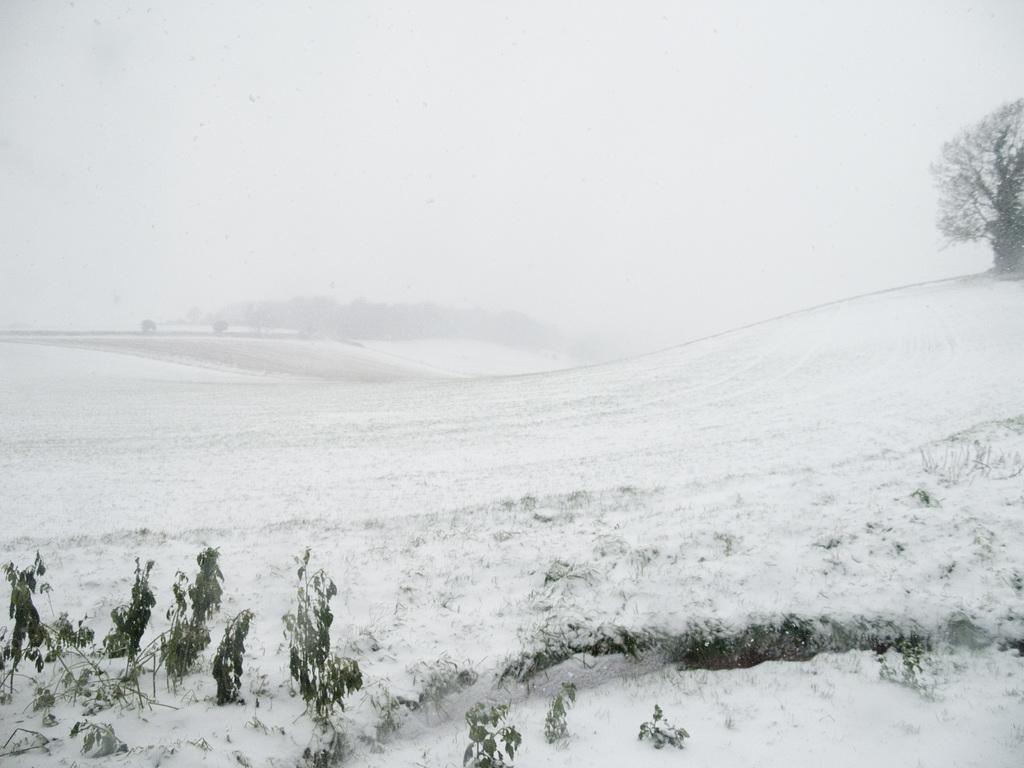Could you give a brief overview of what you see in this image? In this image, we can see a tree and at the bottom, there is snow and there are plants covered by snow. 